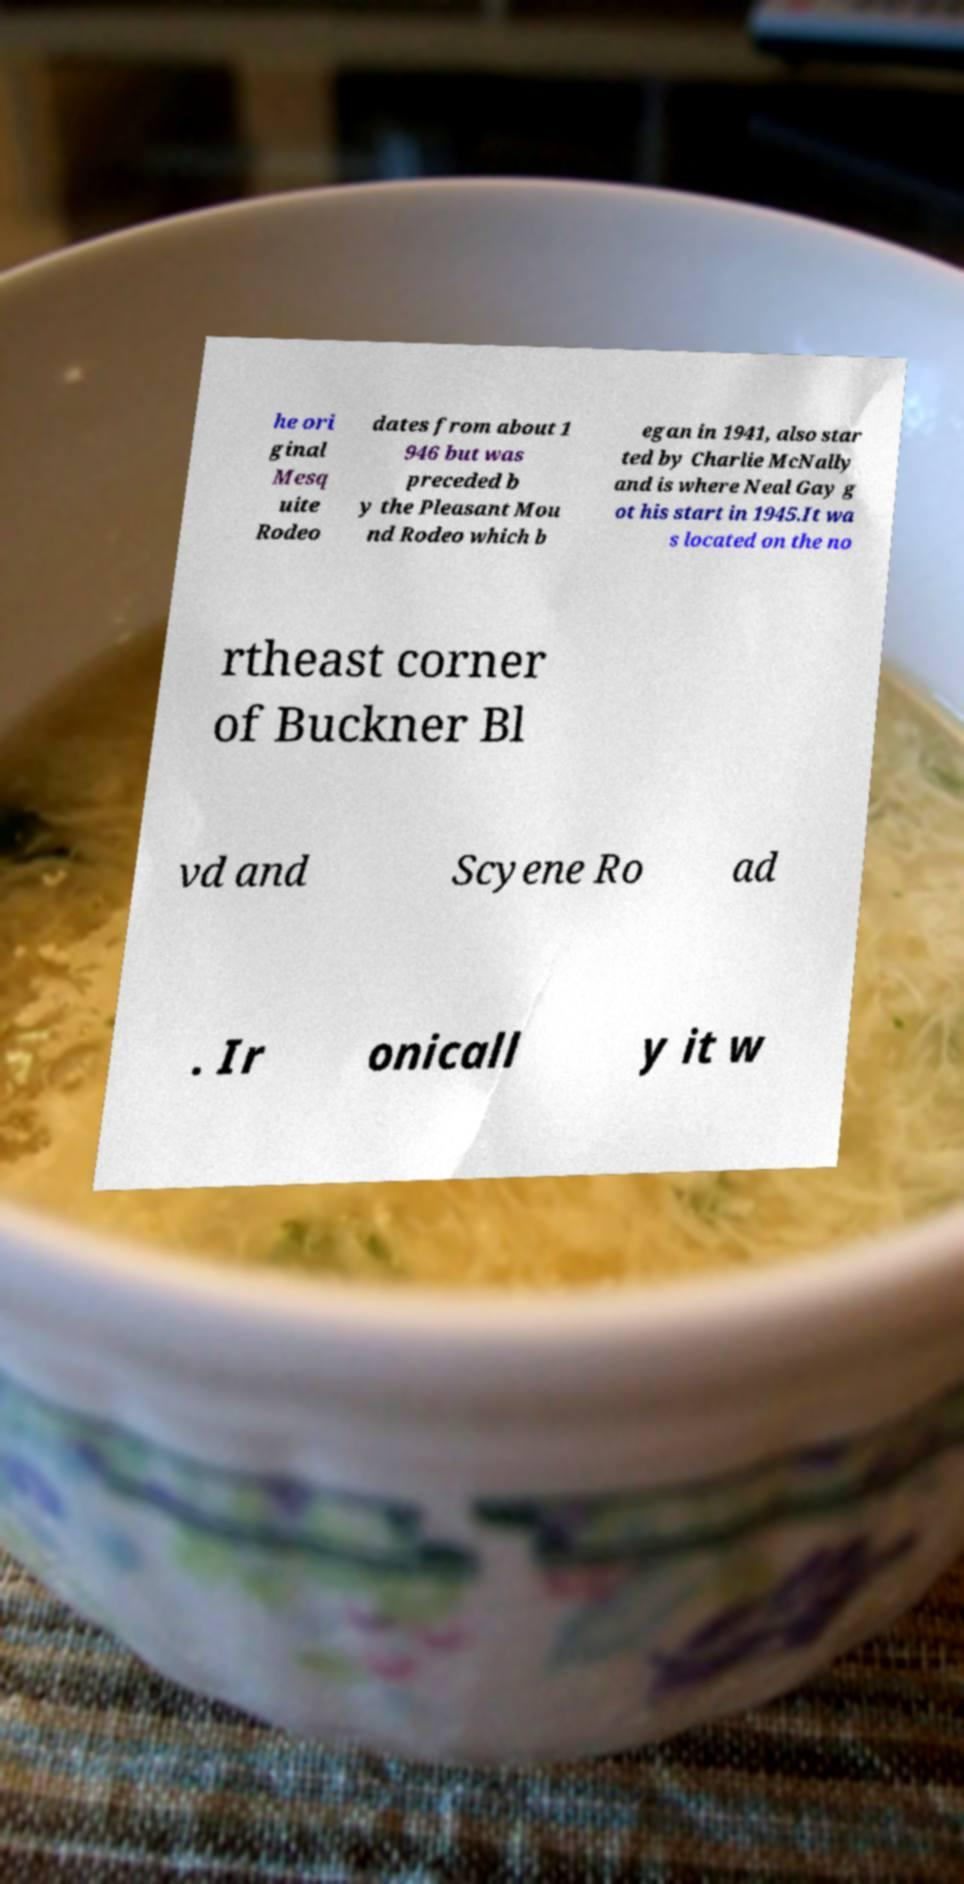There's text embedded in this image that I need extracted. Can you transcribe it verbatim? he ori ginal Mesq uite Rodeo dates from about 1 946 but was preceded b y the Pleasant Mou nd Rodeo which b egan in 1941, also star ted by Charlie McNally and is where Neal Gay g ot his start in 1945.It wa s located on the no rtheast corner of Buckner Bl vd and Scyene Ro ad . Ir onicall y it w 